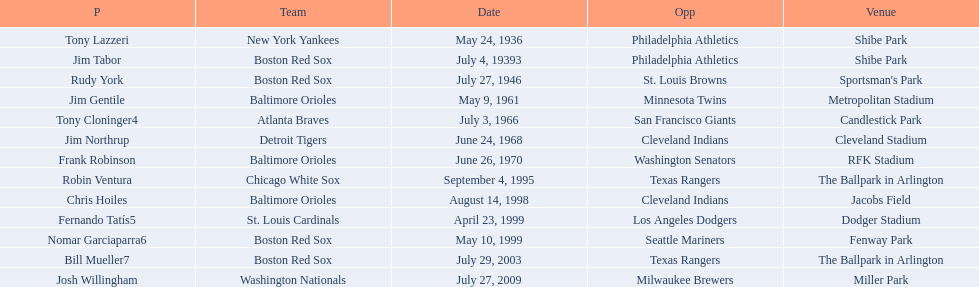What venue did detroit play cleveland in? Cleveland Stadium. Who was the player? Jim Northrup. What date did they play? June 24, 1968. 